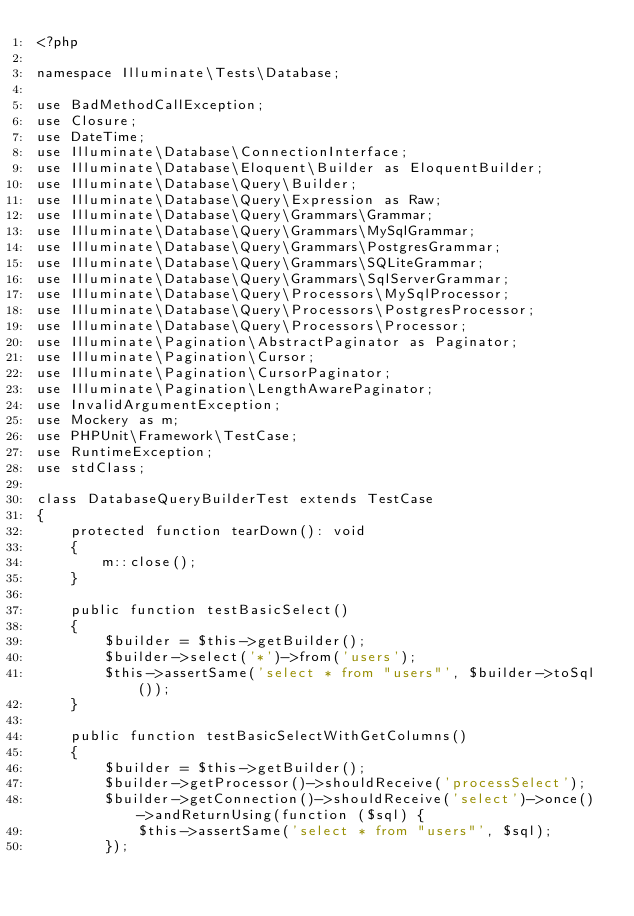Convert code to text. <code><loc_0><loc_0><loc_500><loc_500><_PHP_><?php

namespace Illuminate\Tests\Database;

use BadMethodCallException;
use Closure;
use DateTime;
use Illuminate\Database\ConnectionInterface;
use Illuminate\Database\Eloquent\Builder as EloquentBuilder;
use Illuminate\Database\Query\Builder;
use Illuminate\Database\Query\Expression as Raw;
use Illuminate\Database\Query\Grammars\Grammar;
use Illuminate\Database\Query\Grammars\MySqlGrammar;
use Illuminate\Database\Query\Grammars\PostgresGrammar;
use Illuminate\Database\Query\Grammars\SQLiteGrammar;
use Illuminate\Database\Query\Grammars\SqlServerGrammar;
use Illuminate\Database\Query\Processors\MySqlProcessor;
use Illuminate\Database\Query\Processors\PostgresProcessor;
use Illuminate\Database\Query\Processors\Processor;
use Illuminate\Pagination\AbstractPaginator as Paginator;
use Illuminate\Pagination\Cursor;
use Illuminate\Pagination\CursorPaginator;
use Illuminate\Pagination\LengthAwarePaginator;
use InvalidArgumentException;
use Mockery as m;
use PHPUnit\Framework\TestCase;
use RuntimeException;
use stdClass;

class DatabaseQueryBuilderTest extends TestCase
{
    protected function tearDown(): void
    {
        m::close();
    }

    public function testBasicSelect()
    {
        $builder = $this->getBuilder();
        $builder->select('*')->from('users');
        $this->assertSame('select * from "users"', $builder->toSql());
    }

    public function testBasicSelectWithGetColumns()
    {
        $builder = $this->getBuilder();
        $builder->getProcessor()->shouldReceive('processSelect');
        $builder->getConnection()->shouldReceive('select')->once()->andReturnUsing(function ($sql) {
            $this->assertSame('select * from "users"', $sql);
        });</code> 